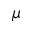Convert formula to latex. <formula><loc_0><loc_0><loc_500><loc_500>\mu</formula> 